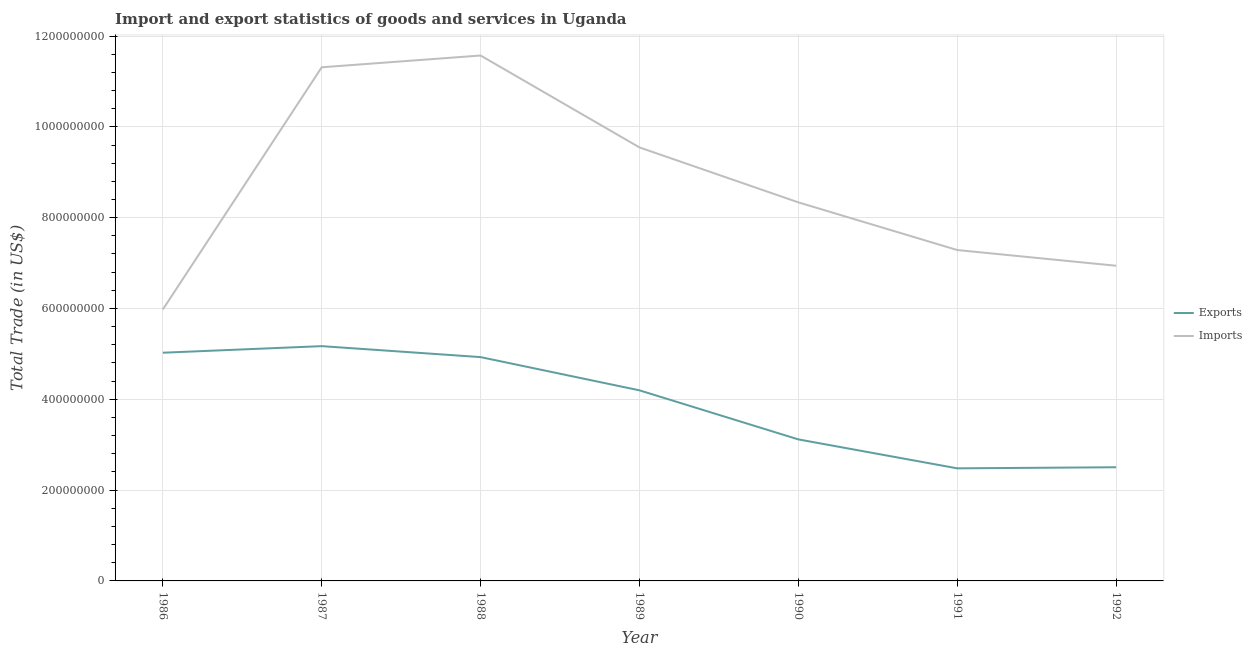Does the line corresponding to export of goods and services intersect with the line corresponding to imports of goods and services?
Ensure brevity in your answer.  No. What is the imports of goods and services in 1992?
Your answer should be very brief. 6.94e+08. Across all years, what is the maximum imports of goods and services?
Provide a short and direct response. 1.16e+09. Across all years, what is the minimum export of goods and services?
Your answer should be compact. 2.48e+08. What is the total imports of goods and services in the graph?
Give a very brief answer. 6.10e+09. What is the difference between the export of goods and services in 1987 and that in 1989?
Provide a succinct answer. 9.73e+07. What is the difference between the export of goods and services in 1991 and the imports of goods and services in 1986?
Give a very brief answer. -3.50e+08. What is the average export of goods and services per year?
Your answer should be very brief. 3.92e+08. In the year 1988, what is the difference between the imports of goods and services and export of goods and services?
Your answer should be very brief. 6.64e+08. In how many years, is the export of goods and services greater than 80000000 US$?
Make the answer very short. 7. What is the ratio of the export of goods and services in 1987 to that in 1990?
Give a very brief answer. 1.66. Is the imports of goods and services in 1986 less than that in 1988?
Make the answer very short. Yes. Is the difference between the export of goods and services in 1988 and 1990 greater than the difference between the imports of goods and services in 1988 and 1990?
Your answer should be compact. No. What is the difference between the highest and the second highest imports of goods and services?
Your answer should be very brief. 2.59e+07. What is the difference between the highest and the lowest export of goods and services?
Provide a succinct answer. 2.69e+08. Is the sum of the export of goods and services in 1987 and 1989 greater than the maximum imports of goods and services across all years?
Offer a very short reply. No. Does the imports of goods and services monotonically increase over the years?
Keep it short and to the point. No. How many lines are there?
Keep it short and to the point. 2. How many years are there in the graph?
Offer a terse response. 7. What is the difference between two consecutive major ticks on the Y-axis?
Keep it short and to the point. 2.00e+08. Are the values on the major ticks of Y-axis written in scientific E-notation?
Keep it short and to the point. No. Does the graph contain any zero values?
Keep it short and to the point. No. Where does the legend appear in the graph?
Your answer should be very brief. Center right. What is the title of the graph?
Offer a terse response. Import and export statistics of goods and services in Uganda. What is the label or title of the X-axis?
Ensure brevity in your answer.  Year. What is the label or title of the Y-axis?
Offer a terse response. Total Trade (in US$). What is the Total Trade (in US$) of Exports in 1986?
Provide a short and direct response. 5.03e+08. What is the Total Trade (in US$) of Imports in 1986?
Provide a succinct answer. 5.98e+08. What is the Total Trade (in US$) of Exports in 1987?
Make the answer very short. 5.17e+08. What is the Total Trade (in US$) of Imports in 1987?
Your response must be concise. 1.13e+09. What is the Total Trade (in US$) in Exports in 1988?
Provide a succinct answer. 4.93e+08. What is the Total Trade (in US$) in Imports in 1988?
Provide a short and direct response. 1.16e+09. What is the Total Trade (in US$) of Exports in 1989?
Provide a succinct answer. 4.20e+08. What is the Total Trade (in US$) in Imports in 1989?
Keep it short and to the point. 9.55e+08. What is the Total Trade (in US$) in Exports in 1990?
Your answer should be compact. 3.12e+08. What is the Total Trade (in US$) of Imports in 1990?
Your answer should be very brief. 8.34e+08. What is the Total Trade (in US$) in Exports in 1991?
Your answer should be very brief. 2.48e+08. What is the Total Trade (in US$) of Imports in 1991?
Your response must be concise. 7.29e+08. What is the Total Trade (in US$) of Exports in 1992?
Give a very brief answer. 2.50e+08. What is the Total Trade (in US$) in Imports in 1992?
Provide a succinct answer. 6.94e+08. Across all years, what is the maximum Total Trade (in US$) in Exports?
Your response must be concise. 5.17e+08. Across all years, what is the maximum Total Trade (in US$) of Imports?
Ensure brevity in your answer.  1.16e+09. Across all years, what is the minimum Total Trade (in US$) of Exports?
Your answer should be very brief. 2.48e+08. Across all years, what is the minimum Total Trade (in US$) in Imports?
Provide a succinct answer. 5.98e+08. What is the total Total Trade (in US$) of Exports in the graph?
Keep it short and to the point. 2.74e+09. What is the total Total Trade (in US$) in Imports in the graph?
Make the answer very short. 6.10e+09. What is the difference between the Total Trade (in US$) of Exports in 1986 and that in 1987?
Offer a terse response. -1.45e+07. What is the difference between the Total Trade (in US$) of Imports in 1986 and that in 1987?
Give a very brief answer. -5.33e+08. What is the difference between the Total Trade (in US$) in Exports in 1986 and that in 1988?
Your answer should be compact. 9.67e+06. What is the difference between the Total Trade (in US$) of Imports in 1986 and that in 1988?
Offer a terse response. -5.59e+08. What is the difference between the Total Trade (in US$) in Exports in 1986 and that in 1989?
Make the answer very short. 8.29e+07. What is the difference between the Total Trade (in US$) in Imports in 1986 and that in 1989?
Provide a succinct answer. -3.57e+08. What is the difference between the Total Trade (in US$) in Exports in 1986 and that in 1990?
Provide a succinct answer. 1.91e+08. What is the difference between the Total Trade (in US$) of Imports in 1986 and that in 1990?
Provide a succinct answer. -2.36e+08. What is the difference between the Total Trade (in US$) of Exports in 1986 and that in 1991?
Keep it short and to the point. 2.55e+08. What is the difference between the Total Trade (in US$) in Imports in 1986 and that in 1991?
Ensure brevity in your answer.  -1.31e+08. What is the difference between the Total Trade (in US$) in Exports in 1986 and that in 1992?
Your answer should be compact. 2.52e+08. What is the difference between the Total Trade (in US$) of Imports in 1986 and that in 1992?
Give a very brief answer. -9.63e+07. What is the difference between the Total Trade (in US$) of Exports in 1987 and that in 1988?
Provide a succinct answer. 2.42e+07. What is the difference between the Total Trade (in US$) in Imports in 1987 and that in 1988?
Make the answer very short. -2.59e+07. What is the difference between the Total Trade (in US$) of Exports in 1987 and that in 1989?
Your answer should be very brief. 9.73e+07. What is the difference between the Total Trade (in US$) of Imports in 1987 and that in 1989?
Provide a short and direct response. 1.77e+08. What is the difference between the Total Trade (in US$) of Exports in 1987 and that in 1990?
Provide a short and direct response. 2.05e+08. What is the difference between the Total Trade (in US$) in Imports in 1987 and that in 1990?
Make the answer very short. 2.98e+08. What is the difference between the Total Trade (in US$) of Exports in 1987 and that in 1991?
Provide a succinct answer. 2.69e+08. What is the difference between the Total Trade (in US$) of Imports in 1987 and that in 1991?
Your answer should be very brief. 4.03e+08. What is the difference between the Total Trade (in US$) in Exports in 1987 and that in 1992?
Offer a very short reply. 2.67e+08. What is the difference between the Total Trade (in US$) of Imports in 1987 and that in 1992?
Your answer should be compact. 4.37e+08. What is the difference between the Total Trade (in US$) in Exports in 1988 and that in 1989?
Provide a succinct answer. 7.32e+07. What is the difference between the Total Trade (in US$) in Imports in 1988 and that in 1989?
Provide a succinct answer. 2.02e+08. What is the difference between the Total Trade (in US$) of Exports in 1988 and that in 1990?
Offer a very short reply. 1.81e+08. What is the difference between the Total Trade (in US$) in Imports in 1988 and that in 1990?
Provide a succinct answer. 3.23e+08. What is the difference between the Total Trade (in US$) of Exports in 1988 and that in 1991?
Make the answer very short. 2.45e+08. What is the difference between the Total Trade (in US$) of Imports in 1988 and that in 1991?
Keep it short and to the point. 4.28e+08. What is the difference between the Total Trade (in US$) in Exports in 1988 and that in 1992?
Make the answer very short. 2.43e+08. What is the difference between the Total Trade (in US$) of Imports in 1988 and that in 1992?
Provide a short and direct response. 4.63e+08. What is the difference between the Total Trade (in US$) of Exports in 1989 and that in 1990?
Make the answer very short. 1.08e+08. What is the difference between the Total Trade (in US$) of Imports in 1989 and that in 1990?
Your answer should be compact. 1.21e+08. What is the difference between the Total Trade (in US$) in Exports in 1989 and that in 1991?
Give a very brief answer. 1.72e+08. What is the difference between the Total Trade (in US$) of Imports in 1989 and that in 1991?
Provide a succinct answer. 2.26e+08. What is the difference between the Total Trade (in US$) in Exports in 1989 and that in 1992?
Offer a terse response. 1.69e+08. What is the difference between the Total Trade (in US$) of Imports in 1989 and that in 1992?
Ensure brevity in your answer.  2.61e+08. What is the difference between the Total Trade (in US$) in Exports in 1990 and that in 1991?
Your response must be concise. 6.37e+07. What is the difference between the Total Trade (in US$) in Imports in 1990 and that in 1991?
Offer a very short reply. 1.05e+08. What is the difference between the Total Trade (in US$) of Exports in 1990 and that in 1992?
Your answer should be very brief. 6.13e+07. What is the difference between the Total Trade (in US$) of Imports in 1990 and that in 1992?
Provide a succinct answer. 1.40e+08. What is the difference between the Total Trade (in US$) of Exports in 1991 and that in 1992?
Offer a terse response. -2.40e+06. What is the difference between the Total Trade (in US$) in Imports in 1991 and that in 1992?
Offer a very short reply. 3.46e+07. What is the difference between the Total Trade (in US$) in Exports in 1986 and the Total Trade (in US$) in Imports in 1987?
Provide a succinct answer. -6.29e+08. What is the difference between the Total Trade (in US$) in Exports in 1986 and the Total Trade (in US$) in Imports in 1988?
Offer a very short reply. -6.55e+08. What is the difference between the Total Trade (in US$) in Exports in 1986 and the Total Trade (in US$) in Imports in 1989?
Keep it short and to the point. -4.52e+08. What is the difference between the Total Trade (in US$) in Exports in 1986 and the Total Trade (in US$) in Imports in 1990?
Keep it short and to the point. -3.31e+08. What is the difference between the Total Trade (in US$) of Exports in 1986 and the Total Trade (in US$) of Imports in 1991?
Make the answer very short. -2.26e+08. What is the difference between the Total Trade (in US$) in Exports in 1986 and the Total Trade (in US$) in Imports in 1992?
Your answer should be very brief. -1.92e+08. What is the difference between the Total Trade (in US$) of Exports in 1987 and the Total Trade (in US$) of Imports in 1988?
Your answer should be compact. -6.40e+08. What is the difference between the Total Trade (in US$) of Exports in 1987 and the Total Trade (in US$) of Imports in 1989?
Provide a short and direct response. -4.38e+08. What is the difference between the Total Trade (in US$) of Exports in 1987 and the Total Trade (in US$) of Imports in 1990?
Make the answer very short. -3.17e+08. What is the difference between the Total Trade (in US$) in Exports in 1987 and the Total Trade (in US$) in Imports in 1991?
Provide a succinct answer. -2.12e+08. What is the difference between the Total Trade (in US$) of Exports in 1987 and the Total Trade (in US$) of Imports in 1992?
Your response must be concise. -1.77e+08. What is the difference between the Total Trade (in US$) in Exports in 1988 and the Total Trade (in US$) in Imports in 1989?
Ensure brevity in your answer.  -4.62e+08. What is the difference between the Total Trade (in US$) of Exports in 1988 and the Total Trade (in US$) of Imports in 1990?
Your response must be concise. -3.41e+08. What is the difference between the Total Trade (in US$) of Exports in 1988 and the Total Trade (in US$) of Imports in 1991?
Give a very brief answer. -2.36e+08. What is the difference between the Total Trade (in US$) of Exports in 1988 and the Total Trade (in US$) of Imports in 1992?
Give a very brief answer. -2.01e+08. What is the difference between the Total Trade (in US$) in Exports in 1989 and the Total Trade (in US$) in Imports in 1990?
Ensure brevity in your answer.  -4.14e+08. What is the difference between the Total Trade (in US$) of Exports in 1989 and the Total Trade (in US$) of Imports in 1991?
Keep it short and to the point. -3.09e+08. What is the difference between the Total Trade (in US$) in Exports in 1989 and the Total Trade (in US$) in Imports in 1992?
Offer a terse response. -2.74e+08. What is the difference between the Total Trade (in US$) of Exports in 1990 and the Total Trade (in US$) of Imports in 1991?
Your response must be concise. -4.17e+08. What is the difference between the Total Trade (in US$) of Exports in 1990 and the Total Trade (in US$) of Imports in 1992?
Make the answer very short. -3.82e+08. What is the difference between the Total Trade (in US$) of Exports in 1991 and the Total Trade (in US$) of Imports in 1992?
Provide a short and direct response. -4.46e+08. What is the average Total Trade (in US$) of Exports per year?
Keep it short and to the point. 3.92e+08. What is the average Total Trade (in US$) of Imports per year?
Provide a succinct answer. 8.71e+08. In the year 1986, what is the difference between the Total Trade (in US$) in Exports and Total Trade (in US$) in Imports?
Provide a succinct answer. -9.53e+07. In the year 1987, what is the difference between the Total Trade (in US$) in Exports and Total Trade (in US$) in Imports?
Offer a terse response. -6.14e+08. In the year 1988, what is the difference between the Total Trade (in US$) in Exports and Total Trade (in US$) in Imports?
Ensure brevity in your answer.  -6.64e+08. In the year 1989, what is the difference between the Total Trade (in US$) in Exports and Total Trade (in US$) in Imports?
Your response must be concise. -5.35e+08. In the year 1990, what is the difference between the Total Trade (in US$) in Exports and Total Trade (in US$) in Imports?
Provide a succinct answer. -5.22e+08. In the year 1991, what is the difference between the Total Trade (in US$) of Exports and Total Trade (in US$) of Imports?
Ensure brevity in your answer.  -4.81e+08. In the year 1992, what is the difference between the Total Trade (in US$) in Exports and Total Trade (in US$) in Imports?
Your answer should be compact. -4.44e+08. What is the ratio of the Total Trade (in US$) in Exports in 1986 to that in 1987?
Make the answer very short. 0.97. What is the ratio of the Total Trade (in US$) in Imports in 1986 to that in 1987?
Offer a terse response. 0.53. What is the ratio of the Total Trade (in US$) of Exports in 1986 to that in 1988?
Offer a terse response. 1.02. What is the ratio of the Total Trade (in US$) of Imports in 1986 to that in 1988?
Provide a succinct answer. 0.52. What is the ratio of the Total Trade (in US$) in Exports in 1986 to that in 1989?
Offer a terse response. 1.2. What is the ratio of the Total Trade (in US$) in Imports in 1986 to that in 1989?
Keep it short and to the point. 0.63. What is the ratio of the Total Trade (in US$) in Exports in 1986 to that in 1990?
Give a very brief answer. 1.61. What is the ratio of the Total Trade (in US$) of Imports in 1986 to that in 1990?
Keep it short and to the point. 0.72. What is the ratio of the Total Trade (in US$) of Exports in 1986 to that in 1991?
Keep it short and to the point. 2.03. What is the ratio of the Total Trade (in US$) of Imports in 1986 to that in 1991?
Give a very brief answer. 0.82. What is the ratio of the Total Trade (in US$) of Exports in 1986 to that in 1992?
Your answer should be very brief. 2.01. What is the ratio of the Total Trade (in US$) in Imports in 1986 to that in 1992?
Your answer should be compact. 0.86. What is the ratio of the Total Trade (in US$) of Exports in 1987 to that in 1988?
Offer a terse response. 1.05. What is the ratio of the Total Trade (in US$) in Imports in 1987 to that in 1988?
Your answer should be very brief. 0.98. What is the ratio of the Total Trade (in US$) in Exports in 1987 to that in 1989?
Provide a short and direct response. 1.23. What is the ratio of the Total Trade (in US$) of Imports in 1987 to that in 1989?
Give a very brief answer. 1.18. What is the ratio of the Total Trade (in US$) in Exports in 1987 to that in 1990?
Offer a terse response. 1.66. What is the ratio of the Total Trade (in US$) in Imports in 1987 to that in 1990?
Keep it short and to the point. 1.36. What is the ratio of the Total Trade (in US$) in Exports in 1987 to that in 1991?
Your answer should be compact. 2.09. What is the ratio of the Total Trade (in US$) in Imports in 1987 to that in 1991?
Provide a succinct answer. 1.55. What is the ratio of the Total Trade (in US$) in Exports in 1987 to that in 1992?
Offer a very short reply. 2.07. What is the ratio of the Total Trade (in US$) in Imports in 1987 to that in 1992?
Your answer should be compact. 1.63. What is the ratio of the Total Trade (in US$) in Exports in 1988 to that in 1989?
Keep it short and to the point. 1.17. What is the ratio of the Total Trade (in US$) of Imports in 1988 to that in 1989?
Provide a short and direct response. 1.21. What is the ratio of the Total Trade (in US$) of Exports in 1988 to that in 1990?
Provide a succinct answer. 1.58. What is the ratio of the Total Trade (in US$) of Imports in 1988 to that in 1990?
Offer a very short reply. 1.39. What is the ratio of the Total Trade (in US$) of Exports in 1988 to that in 1991?
Make the answer very short. 1.99. What is the ratio of the Total Trade (in US$) in Imports in 1988 to that in 1991?
Your response must be concise. 1.59. What is the ratio of the Total Trade (in US$) in Exports in 1988 to that in 1992?
Provide a short and direct response. 1.97. What is the ratio of the Total Trade (in US$) in Imports in 1988 to that in 1992?
Your answer should be very brief. 1.67. What is the ratio of the Total Trade (in US$) of Exports in 1989 to that in 1990?
Offer a terse response. 1.35. What is the ratio of the Total Trade (in US$) of Imports in 1989 to that in 1990?
Your response must be concise. 1.15. What is the ratio of the Total Trade (in US$) in Exports in 1989 to that in 1991?
Offer a very short reply. 1.69. What is the ratio of the Total Trade (in US$) of Imports in 1989 to that in 1991?
Offer a very short reply. 1.31. What is the ratio of the Total Trade (in US$) in Exports in 1989 to that in 1992?
Your response must be concise. 1.68. What is the ratio of the Total Trade (in US$) in Imports in 1989 to that in 1992?
Provide a succinct answer. 1.38. What is the ratio of the Total Trade (in US$) of Exports in 1990 to that in 1991?
Make the answer very short. 1.26. What is the ratio of the Total Trade (in US$) in Imports in 1990 to that in 1991?
Ensure brevity in your answer.  1.14. What is the ratio of the Total Trade (in US$) in Exports in 1990 to that in 1992?
Offer a very short reply. 1.25. What is the ratio of the Total Trade (in US$) of Imports in 1990 to that in 1992?
Your answer should be compact. 1.2. What is the ratio of the Total Trade (in US$) of Imports in 1991 to that in 1992?
Offer a terse response. 1.05. What is the difference between the highest and the second highest Total Trade (in US$) of Exports?
Offer a very short reply. 1.45e+07. What is the difference between the highest and the second highest Total Trade (in US$) of Imports?
Provide a short and direct response. 2.59e+07. What is the difference between the highest and the lowest Total Trade (in US$) of Exports?
Provide a succinct answer. 2.69e+08. What is the difference between the highest and the lowest Total Trade (in US$) of Imports?
Provide a short and direct response. 5.59e+08. 